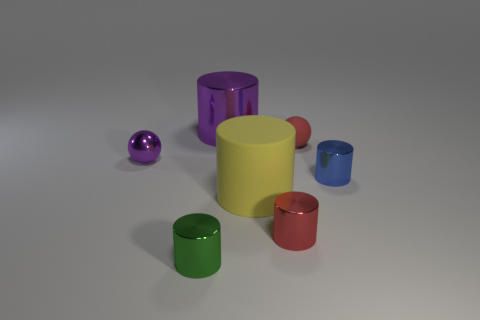Subtract all red cylinders. How many cylinders are left? 4 Subtract 1 cylinders. How many cylinders are left? 4 Subtract all large purple cylinders. How many cylinders are left? 4 Subtract all gray cylinders. Subtract all brown spheres. How many cylinders are left? 5 Add 2 big red metallic cubes. How many objects exist? 9 Subtract all cylinders. How many objects are left? 2 Add 6 small matte balls. How many small matte balls are left? 7 Add 7 blue metal cylinders. How many blue metal cylinders exist? 8 Subtract 0 yellow blocks. How many objects are left? 7 Subtract all tiny blue metal cylinders. Subtract all red spheres. How many objects are left? 5 